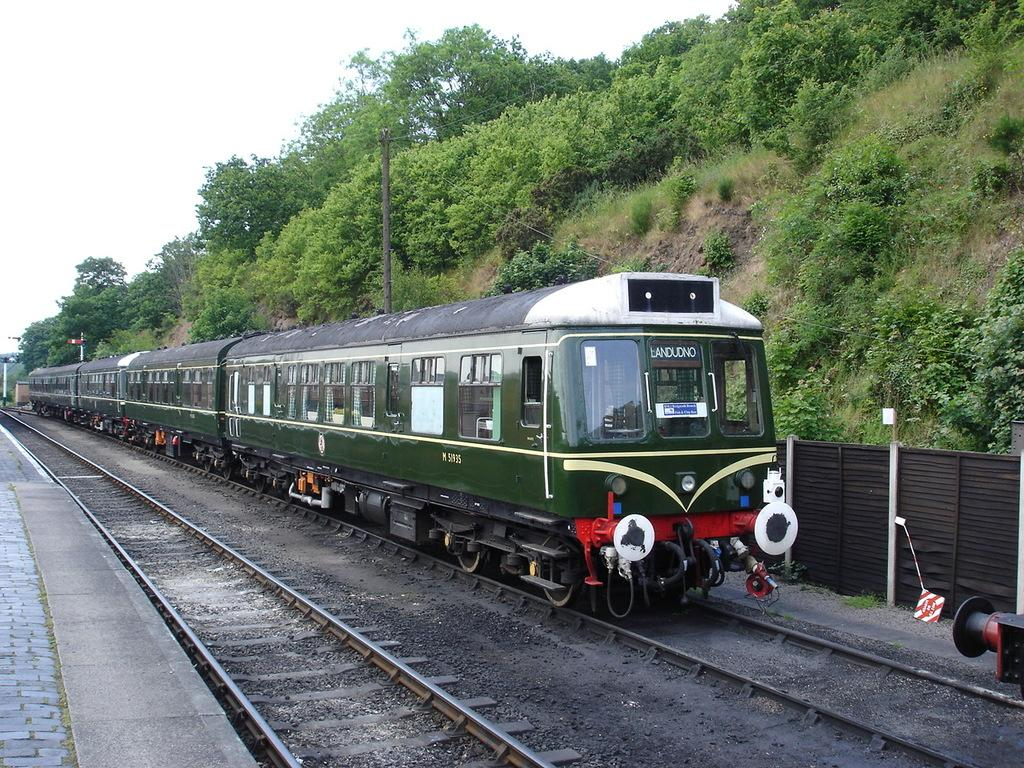What is the main subject of the image? The main subject of the image is a train on a track. Can you describe the surroundings of the train track? There is another track and path beside the train track. What can be seen in the background of the image? There is fencing, poles, trees, and the sky visible in the background of the image. What time of day is it in the image, considering the presence of the moon? There is no moon present in the image; it only shows a train on a track, a track and path beside it, and various elements in the background. What type of seed can be seen growing near the train track? There is no seed visible in the image; it only shows a train on a track, a track and path beside it, and various elements in the background. 